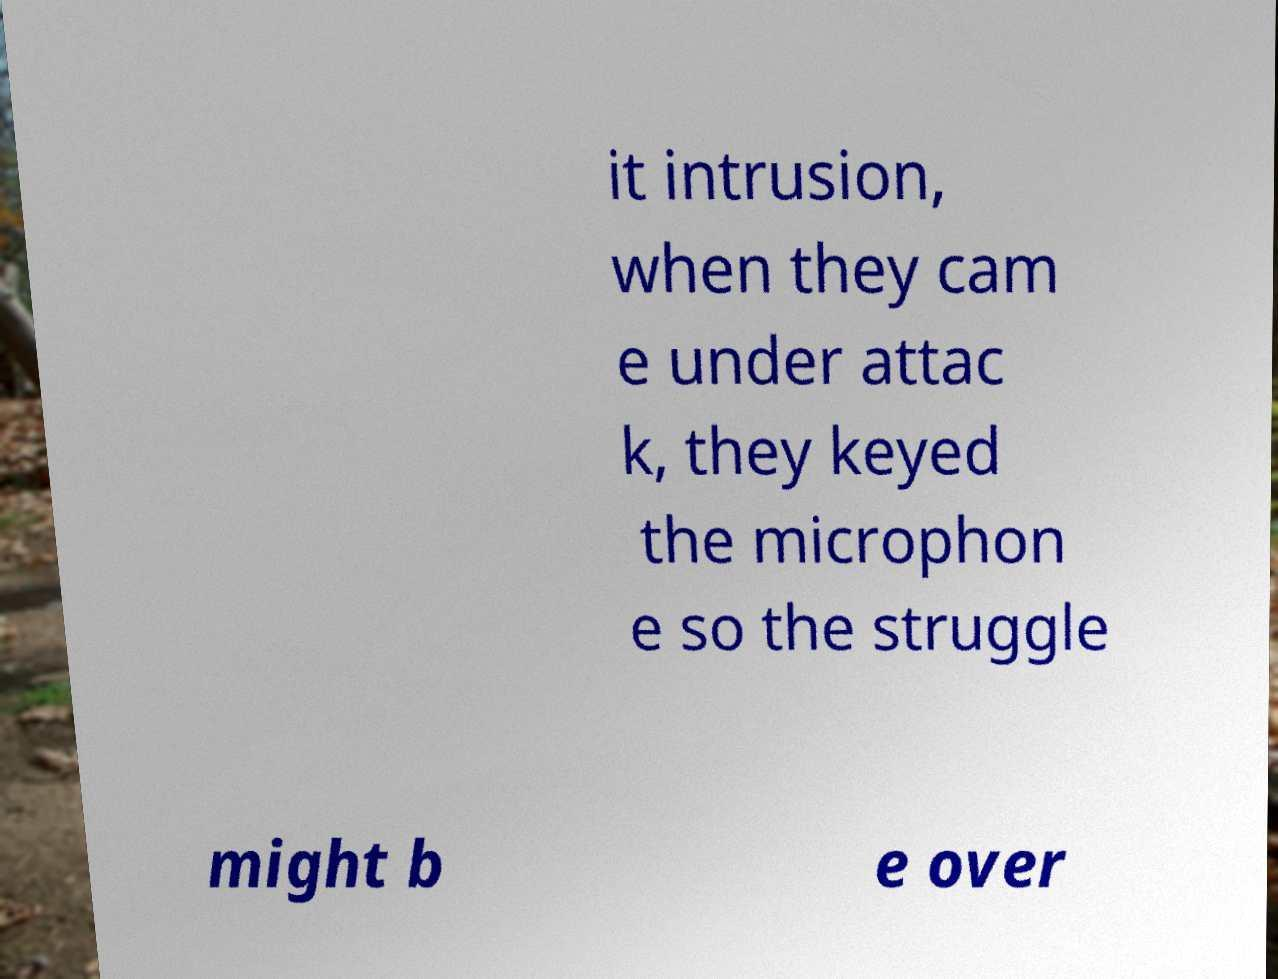Can you read and provide the text displayed in the image?This photo seems to have some interesting text. Can you extract and type it out for me? it intrusion, when they cam e under attac k, they keyed the microphon e so the struggle might b e over 